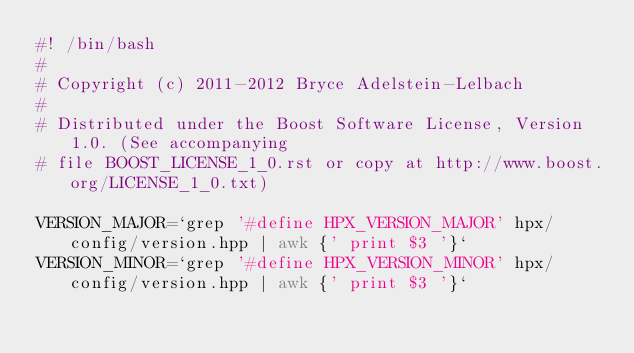<code> <loc_0><loc_0><loc_500><loc_500><_Bash_>#! /bin/bash
#
# Copyright (c) 2011-2012 Bryce Adelstein-Lelbach
#
# Distributed under the Boost Software License, Version 1.0. (See accompanying
# file BOOST_LICENSE_1_0.rst or copy at http://www.boost.org/LICENSE_1_0.txt)

VERSION_MAJOR=`grep '#define HPX_VERSION_MAJOR' hpx/config/version.hpp | awk {' print $3 '}`
VERSION_MINOR=`grep '#define HPX_VERSION_MINOR' hpx/config/version.hpp | awk {' print $3 '}`</code> 